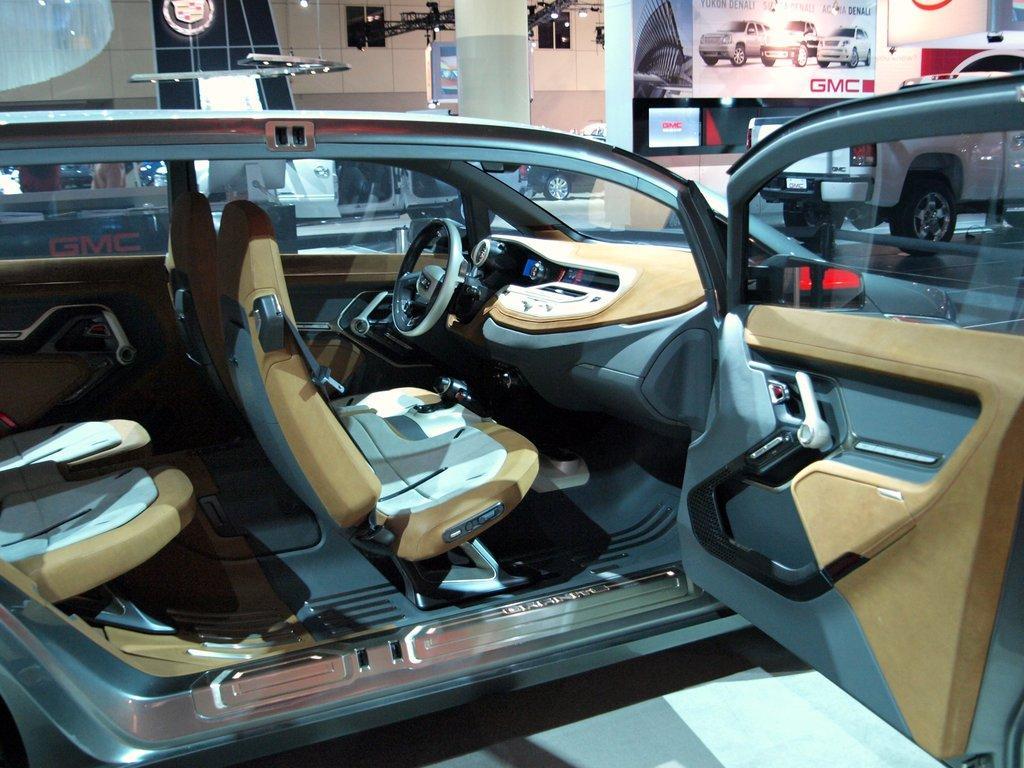Can you describe this image briefly? In this picture we can observe a car. On the right side there is a door opened. We can observe steering. This car is in the showroom. In the background we can observe a pillar, poster and a wall. 